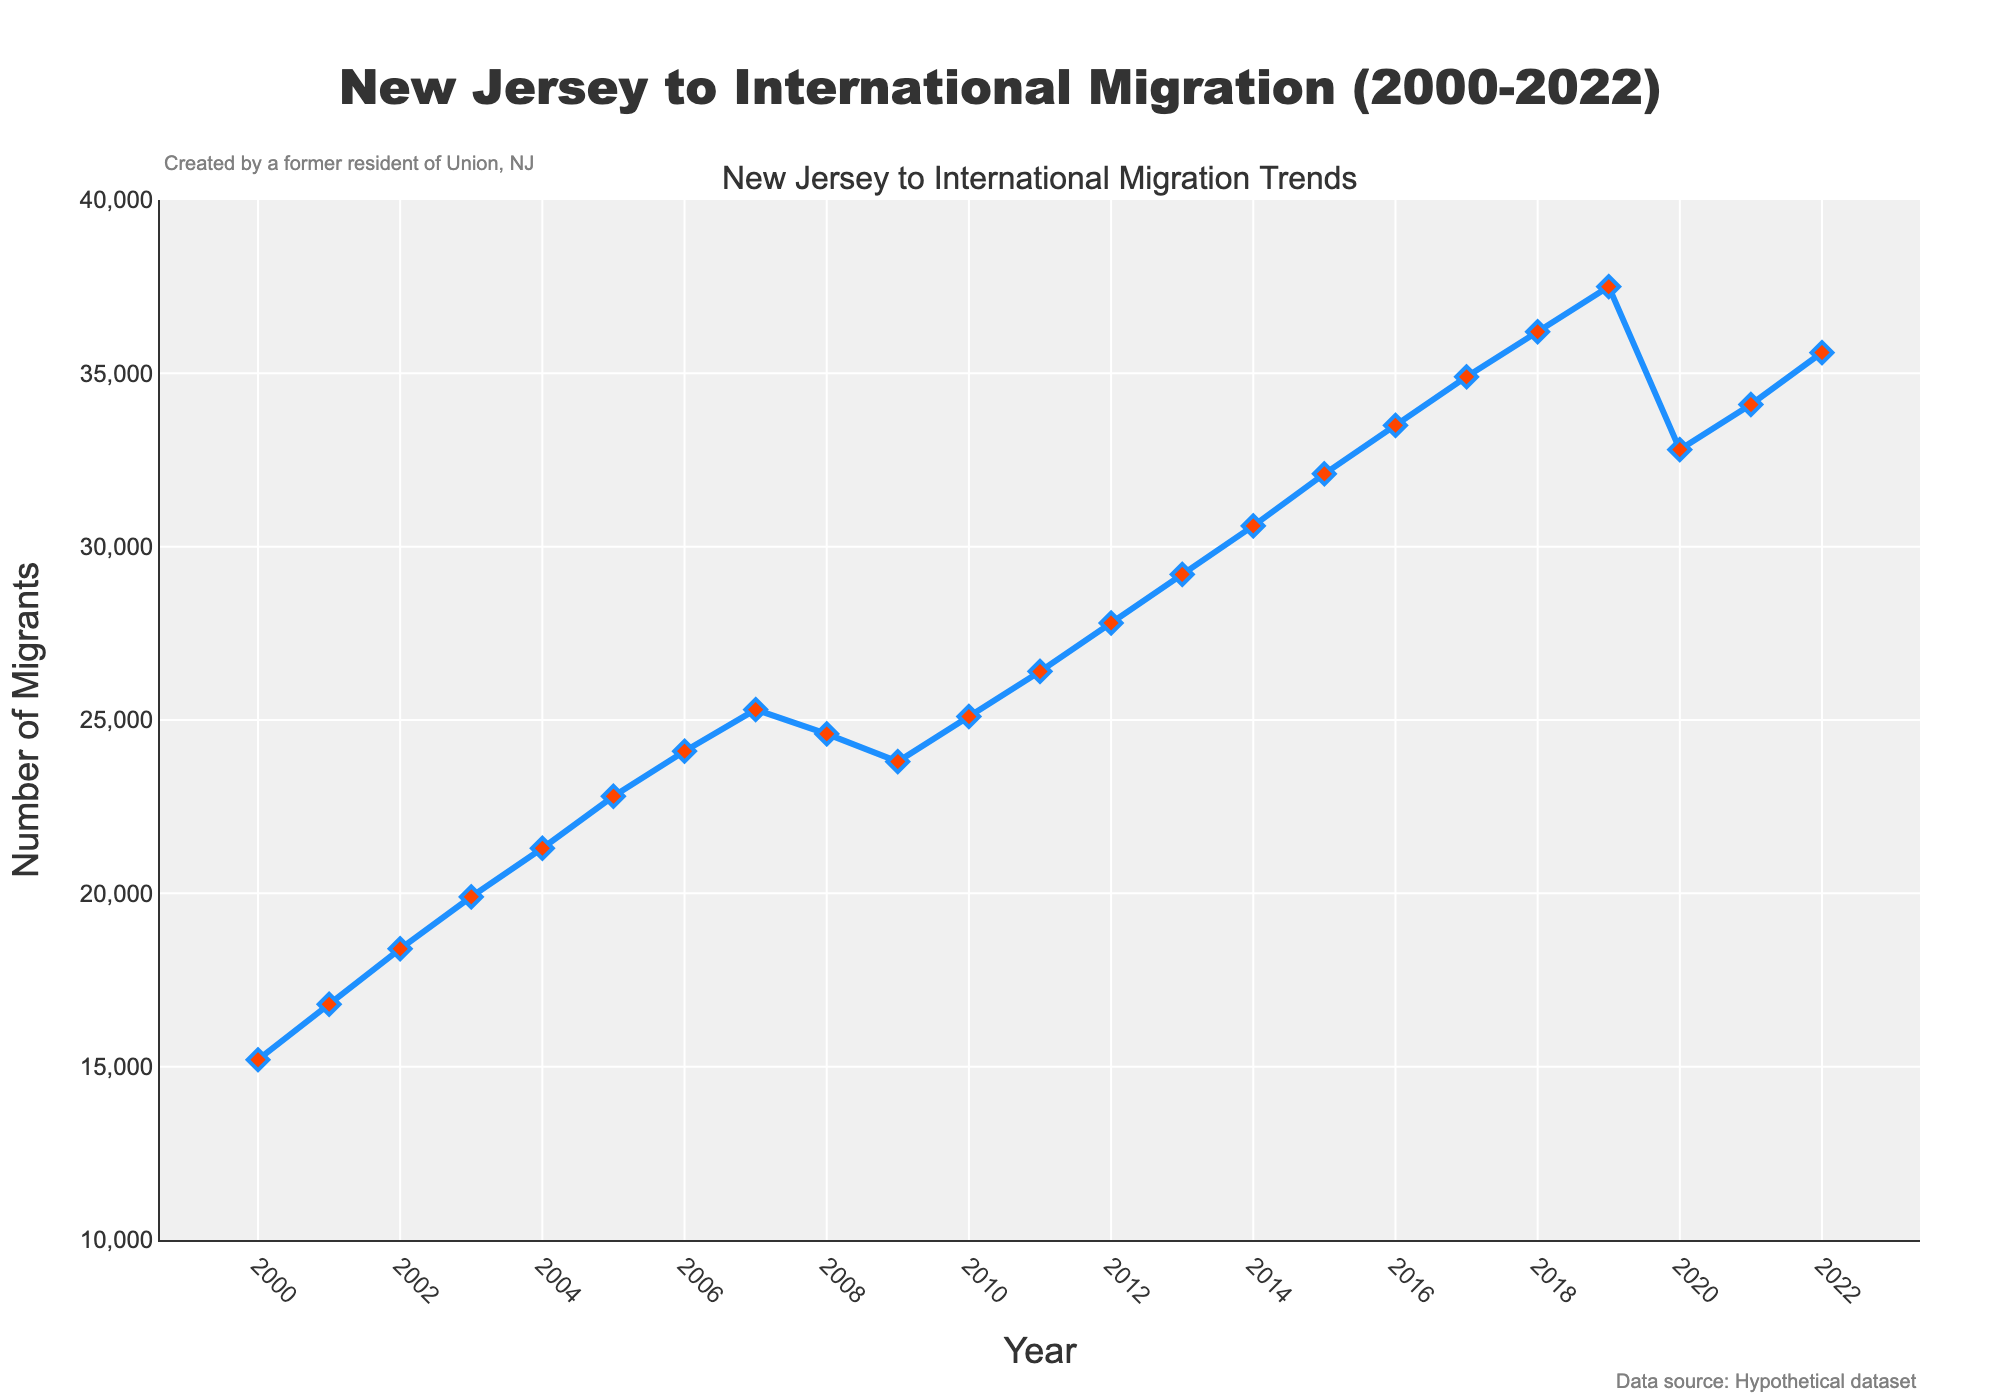What's the general trend in New Jersey to international migration from 2000 to 2022? By looking at the figure, the general trend shows an overall increase in migration numbers from 2000 to 2022, with some fluctuations around 2008-2010 and a dip in 2020.
Answer: Increasing What was the lowest number of migrants from New Jersey to international destinations in the given period? To find the lowest number, look at the figure and find the lowest point on the line. The lowest number was in 2000 with 15,200 migrants.
Answer: 15,200 How did the migration numbers change from 2009 to 2010? Examine the values at 2009 and 2010. The number of migrants increased from 23,800 in 2009 to 25,100 in 2010. The change is 25,100 - 23,800.
Answer: Increased by 1,300 Was the migration higher in 2015 or in 2020? Compare the points for the years 2015 and 2020. The migration was higher in 2015 with 32,100 migrants compared to 32,800 in 2020.
Answer: Higher in 2015 What's the average number of migrants from 2000 to 2005? Calculate the average for the years 2000 to 2005: (15,200 + 16,800 + 18,400 + 19,900 + 21,300 + 22,800) / 6 = 114,400 / 6 = 19,067.
Answer: 19,067 Did the migration numbers reach 30,000 in any year between 2000 and 2010? Look for any point in the given time span where the migration reaches or exceeds 30,000. The migration numbers did not reach 30,000 in any year between 2000 and 2010.
Answer: No How do the migration numbers in 2018 and 2022 compare to each other? Comparing the points for 2018 and 2022, both are close in value, with 2018 having 36,200 and 2022 slightly higher at 35,600.
Answer: 2022 is slightly lower What is the percentage increase in migration from 2000 to 2022? Calculate the percentage increase: 
((35,600 - 15,200) / 15,200) * 100 = (20,400 / 15,200) * 100 ≈ 134.21%
Answer: 134.21% Which year experienced the largest single-year increase in migration numbers? Look for the steepest upward slope between consecutive years. The largest single-year increase was between 2018 and 2019, with an increase from 36,200 to 37,500, a difference of 1,300.
Answer: 2018-2019 What happened to the migration numbers in 2008 compared to the previous year? Compare the values of 2007 and 2008. Migration decreased from 25,300 in 2007 to 24,600 in 2008. The number dropped by 700.
Answer: Decreased by 700 